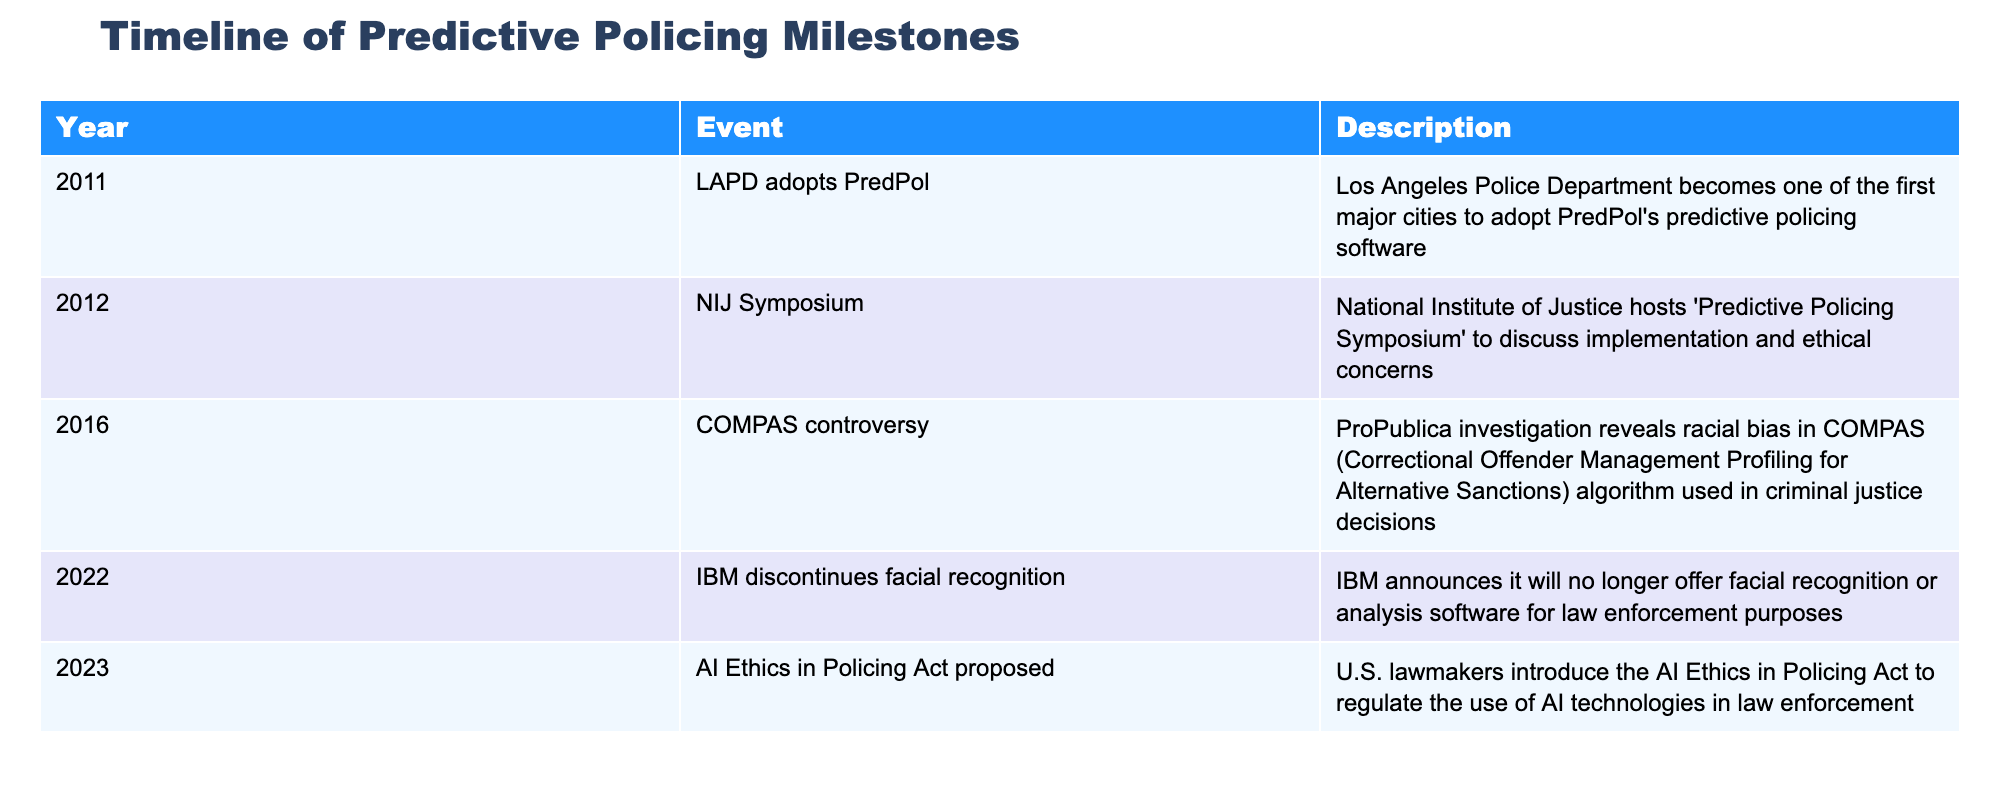What year did the LAPD adopt PredPol? The table lists 2011 as the year when the LAPD adopted PredPol as their predictive policing software.
Answer: 2011 What event took place in 2012? According to the table, the National Institute of Justice hosted the "Predictive Policing Symposium" in 2012.
Answer: NIJ Symposium How many events occurred before 2016? There are two events before 2016: the LAPD adopts PredPol in 2011 and the NIJ Symposium in 2012.
Answer: 2 Was there a controversy related to predictive policing algorithms? Yes, the table mentions the COMPAS controversy in 2016, revealing racial bias in the algorithm.
Answer: Yes What is the time gap between the adoption of PredPol and the introduction of the AI Ethics in Policing Act? The adoption of PredPol was in 2011 and the introduction of the AI Ethics in Policing Act was in 2023. The time gap is 2023 - 2011 = 12 years.
Answer: 12 years How many total events are listed in the timeline? The table contains five distinct events related to predictive policing milestones from 2011 to 2023.
Answer: 5 Did IBM announce discontinuing facial recognition software before or after 2020? The table indicates that IBM discontinued its facial recognition software in 2022, which is after 2020.
Answer: After What was the first major city to adopt a predictive policing algorithm? The first major city listed in the table to adopt a predictive policing algorithm was Los Angeles, with their adoption of PredPol in 2011.
Answer: Los Angeles What event occurred immediately after the COMPAS controversy? The event that followed the COMPAS controversy was IBM discontinuing facial recognition software in 2022.
Answer: IBM discontinues facial recognition 